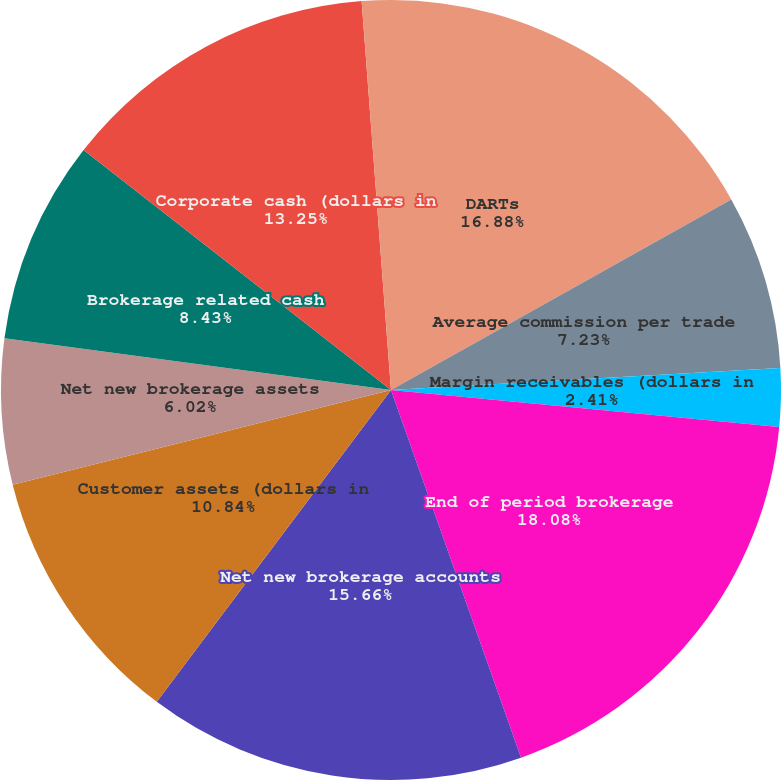<chart> <loc_0><loc_0><loc_500><loc_500><pie_chart><fcel>DARTs<fcel>Average commission per trade<fcel>Margin receivables (dollars in<fcel>End of period brokerage<fcel>Net new brokerage accounts<fcel>Customer assets (dollars in<fcel>Net new brokerage assets<fcel>Brokerage related cash<fcel>Corporate cash (dollars in<fcel>ETRADE Financial Tier 1<nl><fcel>16.87%<fcel>7.23%<fcel>2.41%<fcel>18.07%<fcel>15.66%<fcel>10.84%<fcel>6.02%<fcel>8.43%<fcel>13.25%<fcel>1.2%<nl></chart> 